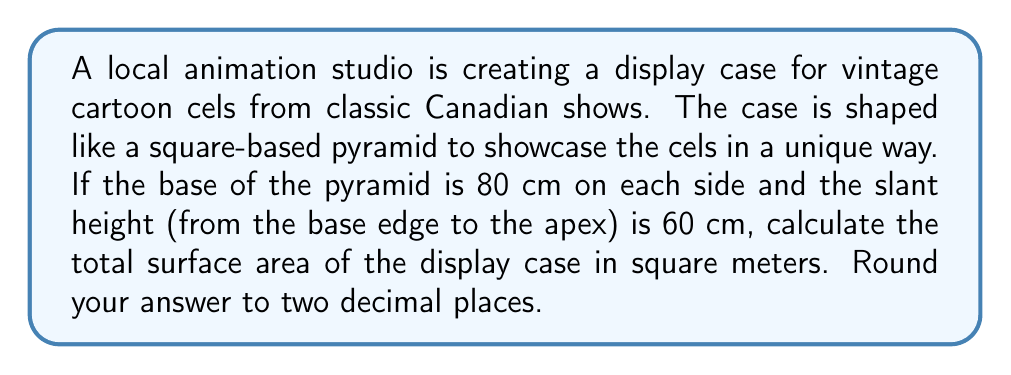Help me with this question. Let's approach this step-by-step:

1) First, we need to identify the components of the surface area:
   - The square base
   - Four triangular faces

2) Calculate the area of the square base:
   $$A_{base} = s^2 = 80^2 = 6400 \text{ cm}^2$$

3) For each triangular face:
   - Base of the triangle is 80 cm
   - Height of the triangle (slant height) is 60 cm
   - Area of one triangular face: $$A_{face} = \frac{1}{2} \times 80 \times 60 = 2400 \text{ cm}^2$$

4) Total area of the four triangular faces:
   $$A_{faces} = 4 \times 2400 = 9600 \text{ cm}^2$$

5) Total surface area:
   $$A_{total} = A_{base} + A_{faces} = 6400 + 9600 = 16000 \text{ cm}^2$$

6) Convert to square meters:
   $$A_{total} = 16000 \text{ cm}^2 \times \frac{1 \text{ m}^2}{10000 \text{ cm}^2} = 1.6 \text{ m}^2$$

Therefore, the total surface area of the pyramid-shaped display case is 1.60 m² when rounded to two decimal places.

[asy]
import geometry;

unitsize(1cm);

pair A = (0,0), B = (8,0), C = (8,8), D = (0,8);
pair E = (4,4);
pair F = (4,7);

draw(A--B--C--D--cycle);
draw(A--E, dashed);
draw(B--E, dashed);
draw(C--E, dashed);
draw(D--E, dashed);
draw(A--F);
draw(B--F);
draw(C--F);
draw(D--F);

label("80 cm", (A+B)/2, S);
label("60 cm", (A+F)/2, NW);
label("E", E, SE);

</asy]
Answer: 1.60 m² 